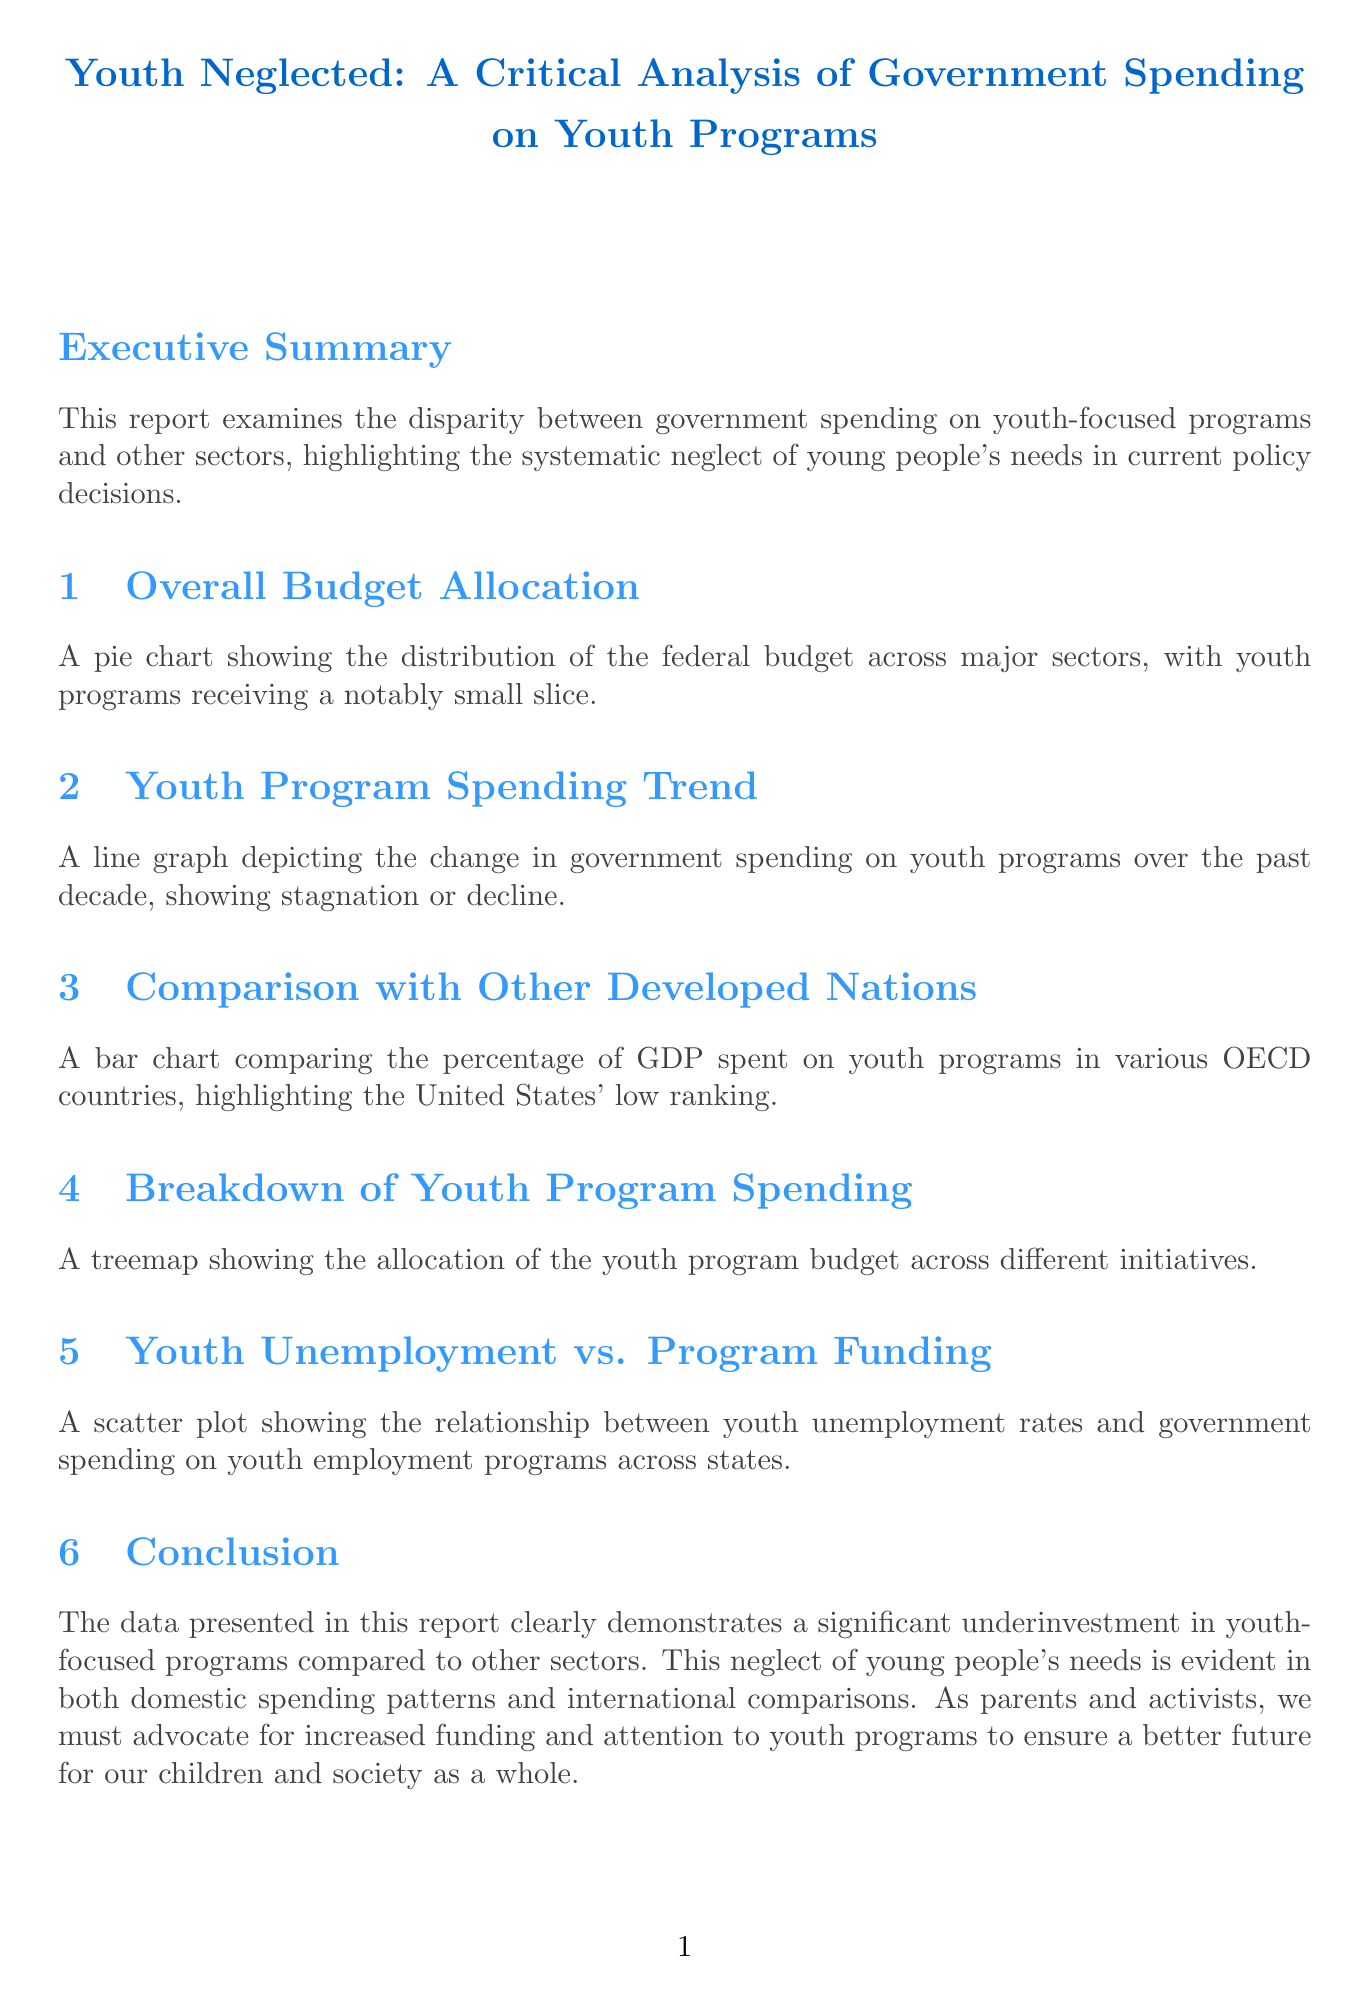What is the report title? The title of the report is stated at the beginning of the document.
Answer: Youth Neglected: A Critical Analysis of Government Spending on Youth Programs What percentage of the federal budget is allocated to youth programs? The report mentions the allocation of youth programs in the overall budget allocation section.
Answer: 3 What years are depicted in the Youth Program Spending Trend graph? The years represented in the line graph for spending trends are listed in the respective section.
Answer: 2013 to 2022 Which country spends the most on youth programs according to the comparison? The bar chart compares the spending among OECD countries, identifying the country with the highest percentage.
Answer: Sweden What is the percentage of youth program spending in the United States? The report provides data in a specific section that highlights the U.S. standing in youth-focused spending.
Answer: 0.8 How many categories are listed in the Breakdown of Youth Program Spending? The treemap section outlines different categories for youth program allocation.
Answer: 7 What recommendation suggests creating tax incentives? The recommendations section contains various proposals to improve youth program funding and engagement.
Answer: Create tax incentives for businesses that invest in youth employment and training programs What is the relationship shown in the Youth Unemployment vs. Program Funding scatter plot? The scatter plot section describes the correlation between two different datasets.
Answer: Youth unemployment rates and government spending on youth employment programs What is the conclusion of the report? The conclusion summarizes the overall findings and implications discussed throughout the report.
Answer: Significant underinvestment in youth-focused programs compared to other sectors 